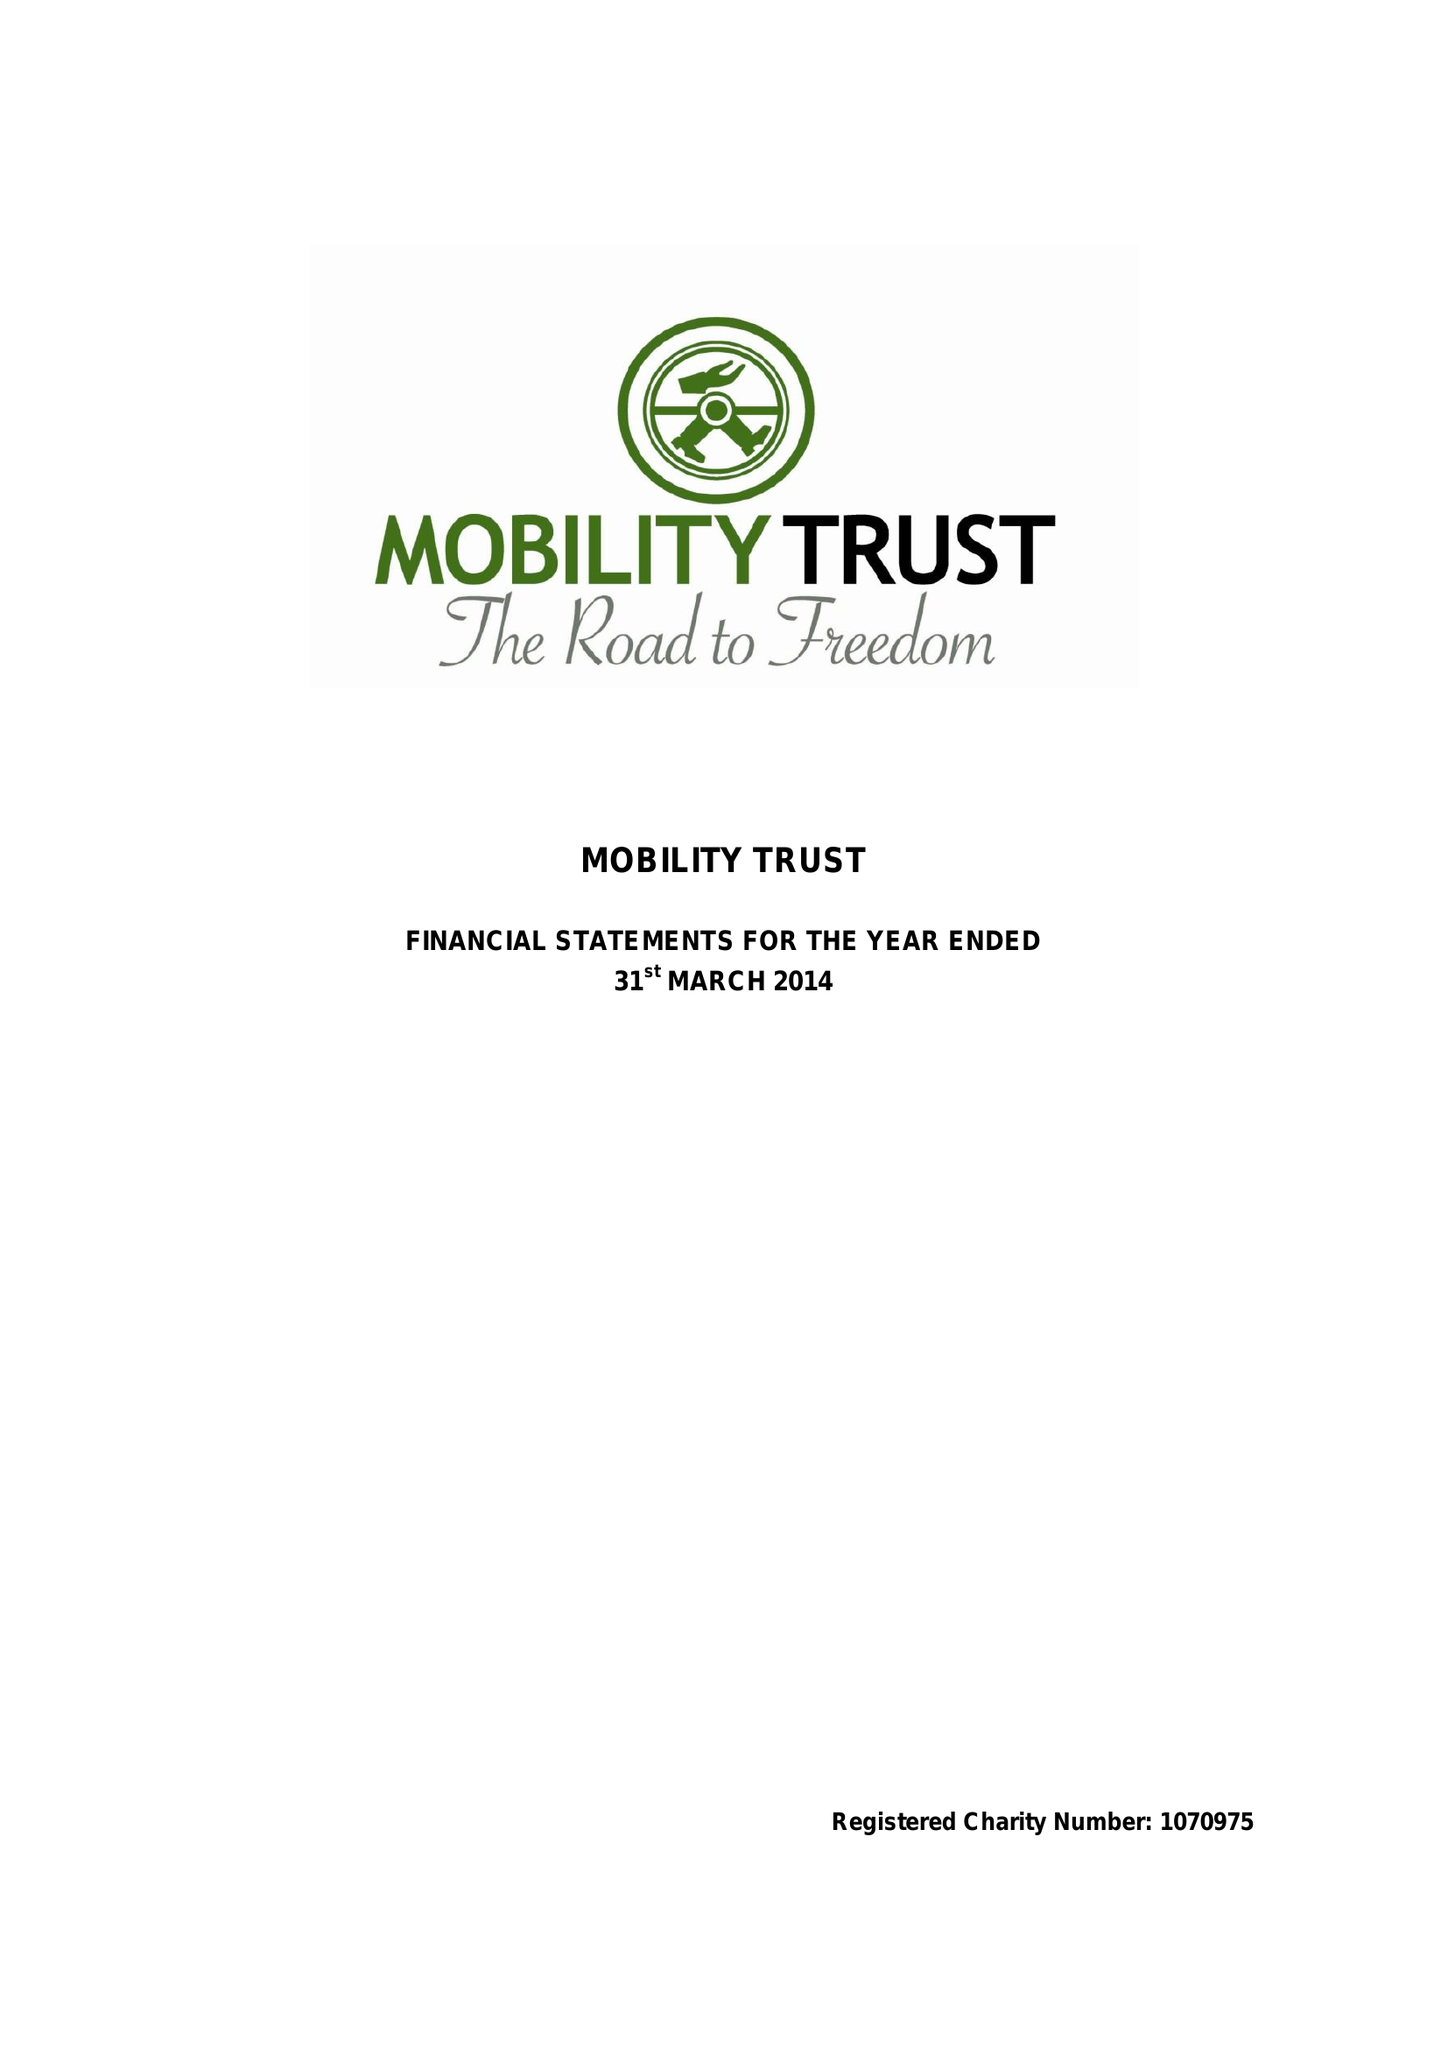What is the value for the address__postcode?
Answer the question using a single word or phrase. RG8 7LR 